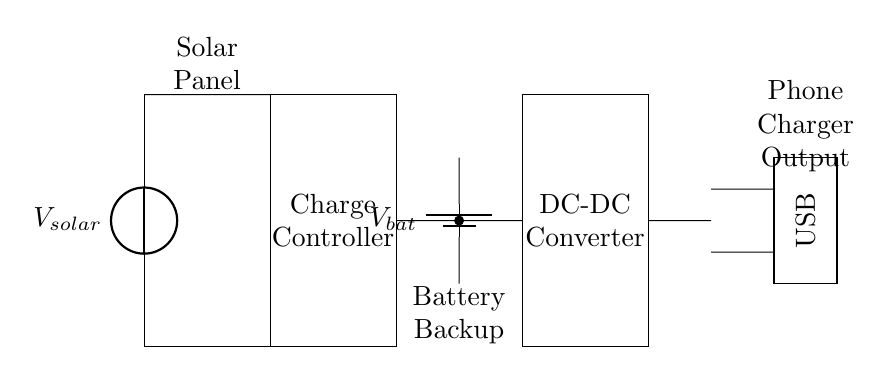What is the voltage source type used in this circuit? The circuit includes a solar panel as the voltage source, indicated by the label V_solar.
Answer: Solar panel What component acts as a battery backup in this circuit? The circuit has a battery component labeled V_bat, providing backup power when needed.
Answer: Battery How many main components are there in this circuit? There are four main components: a solar panel, a charge controller, a battery backup, and a DC-DC converter.
Answer: Four What is the purpose of the DC-DC converter in this circuit? The DC-DC converter transforms the voltage from the battery to a suitable level for USB charging, ensuring compatibility with devices.
Answer: Voltage transformation What connections are made directly between the charge controller and the battery? The circuit shows a direct connection between the charge controller and the battery, which allows for charging the battery from solar energy.
Answer: Direct connection Which output type is available from this circuit for charging devices? The circuit provides a USB output labeled as Phone Charger Output, which is the connection point for charging devices.
Answer: USB What is the arrangement of the components in terms of voltage flow? The voltage flows from the solar panel to the charge controller, then to the battery and finally through the DC-DC converter to the USB output.
Answer: Series arrangement 